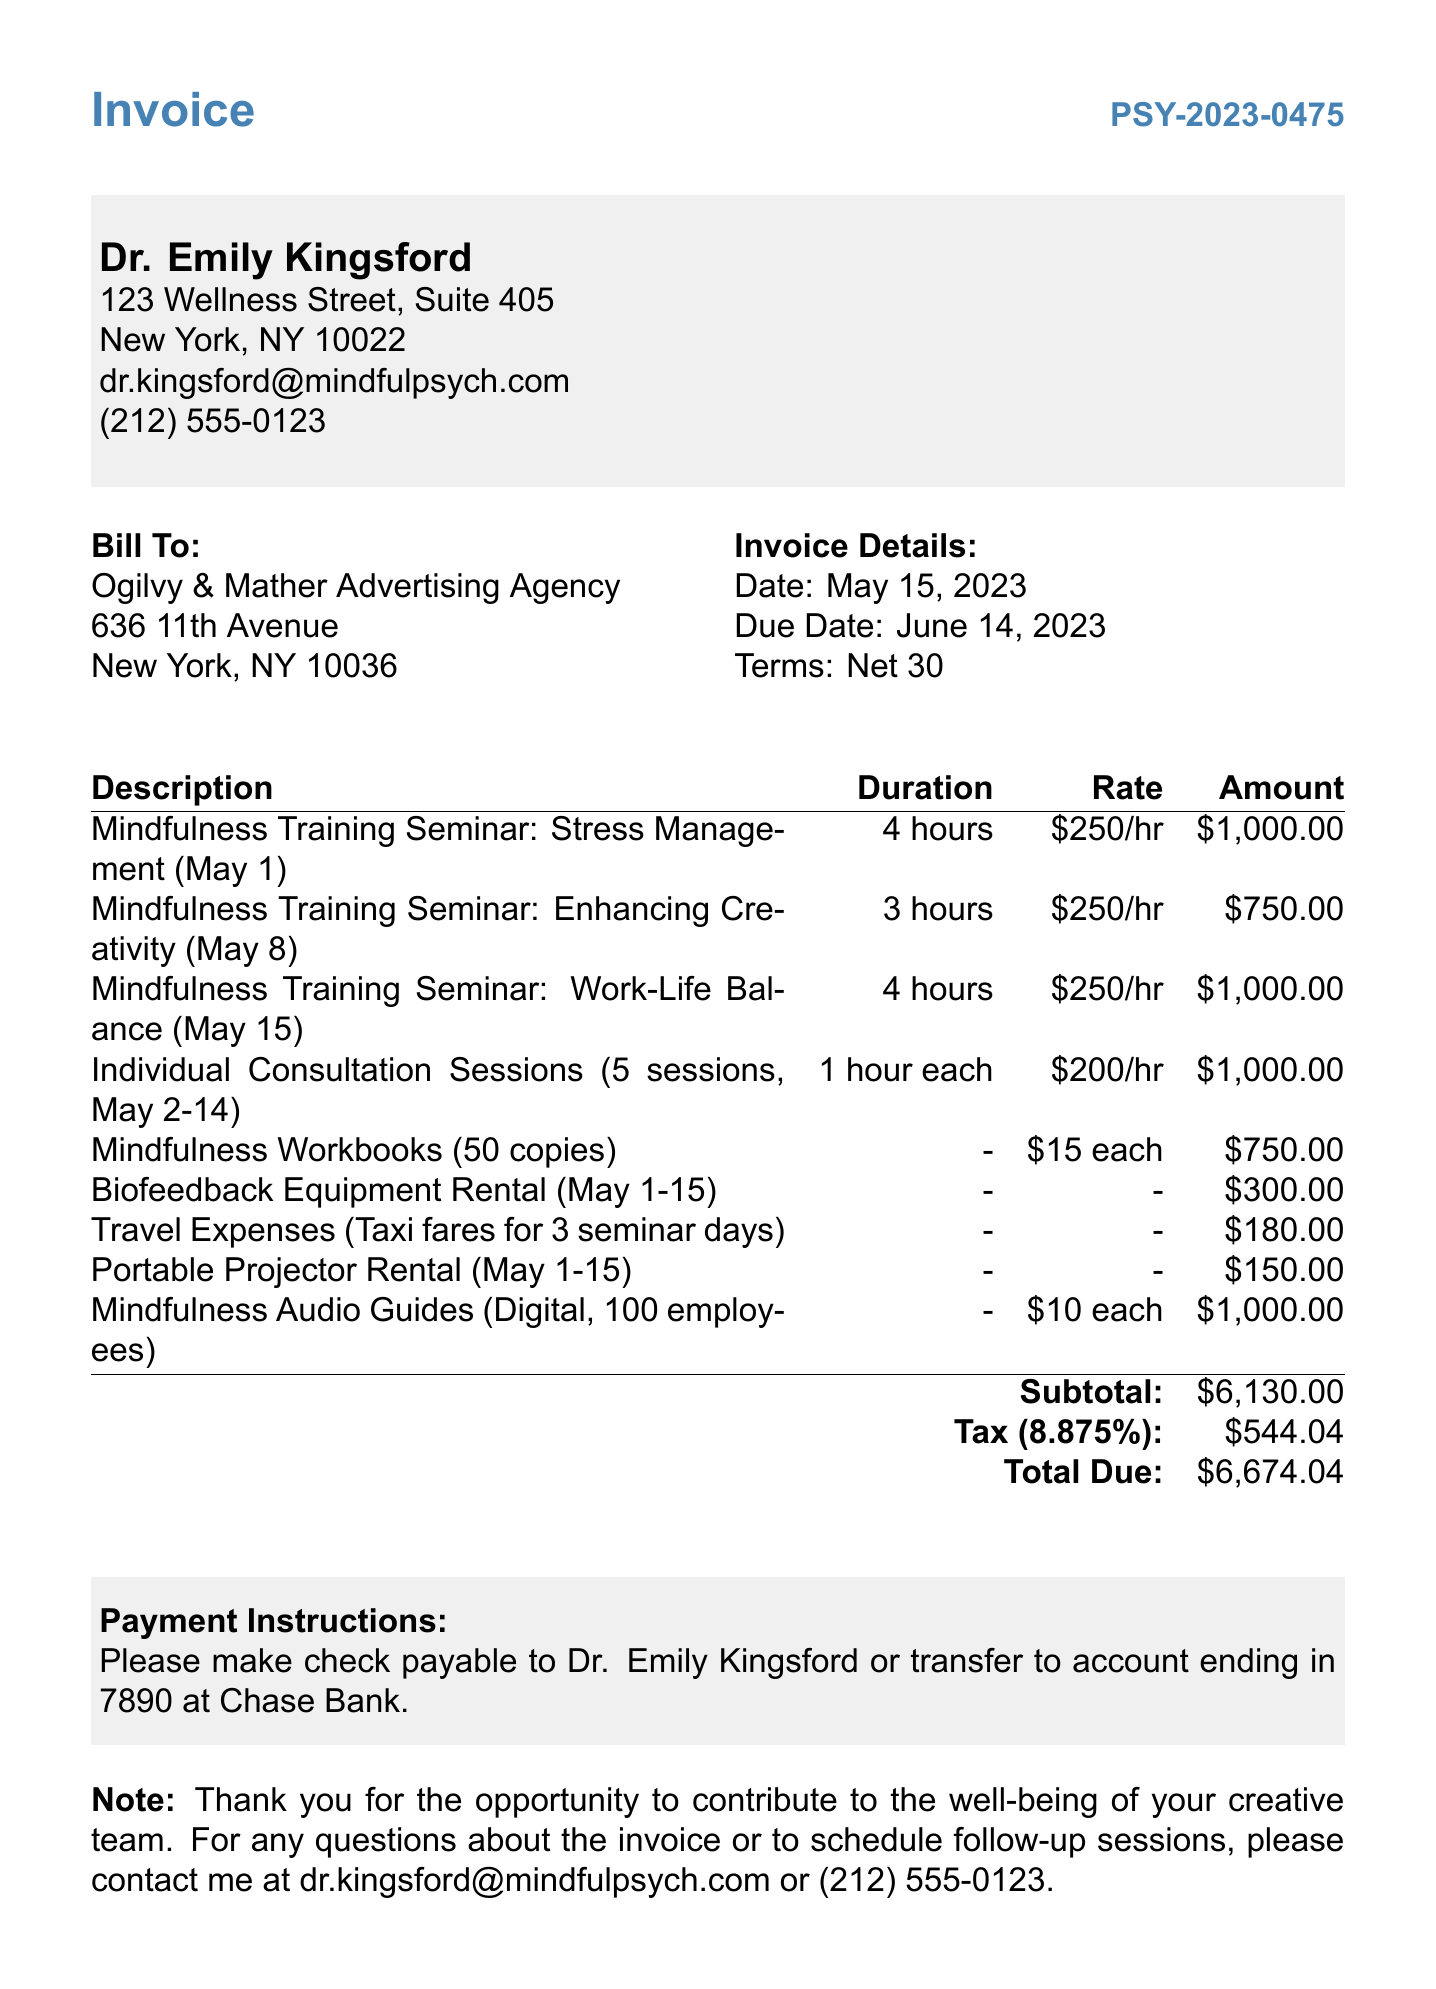What is the invoice number? The invoice number is listed prominently at the top of the document.
Answer: PSY-2023-0475 Who is the client? The client name is specified in the "Bill To" section of the invoice.
Answer: Ogilvy & Mather Advertising Agency What is the total amount due? The total amount is calculated and displayed at the bottom of the invoice.
Answer: 6674.04 What is the tax rate applied? The tax rate is mentioned in connection with the tax amount calculations.
Answer: 8.875% How many mindfulness workbooks were provided? The quantity of mindfulness workbooks is specified under the itemized list.
Answer: 50 copies What was the duration of the seminar on May 8? The duration for each seminar is listed along with the description.
Answer: 3 hours What is the payment term? The payment terms are mentioned in a dedicated section on the invoice.
Answer: Net 30 What date was the invoice issued? The issue date appears in the "Invoice Details" section.
Answer: May 15, 2023 What are the travel expenses for? The description categorized under travel expenses indicates the purpose.
Answer: Taxi fares for 3 seminar days 